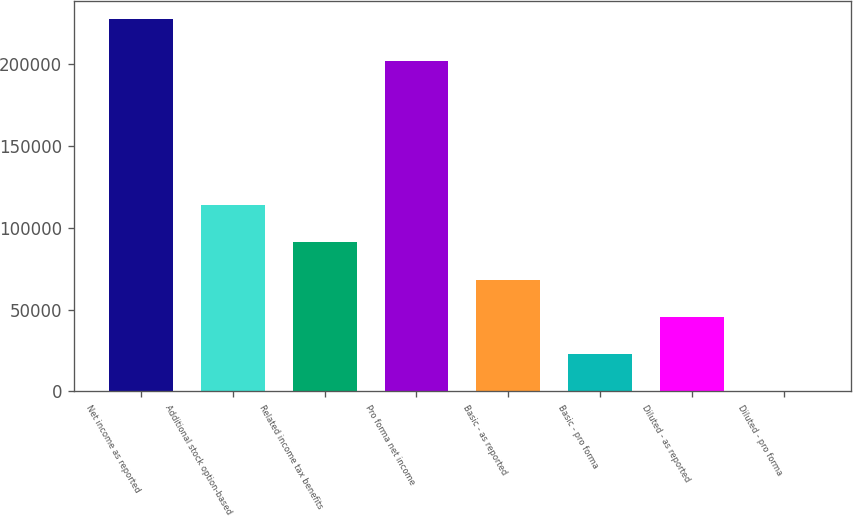Convert chart. <chart><loc_0><loc_0><loc_500><loc_500><bar_chart><fcel>Net income as reported<fcel>Additional stock option-based<fcel>Related income tax benefits<fcel>Pro forma net income<fcel>Basic - as reported<fcel>Basic - pro forma<fcel>Diluted - as reported<fcel>Diluted - pro forma<nl><fcel>227487<fcel>113744<fcel>90995.8<fcel>201707<fcel>68247.2<fcel>22750.1<fcel>45498.7<fcel>1.59<nl></chart> 